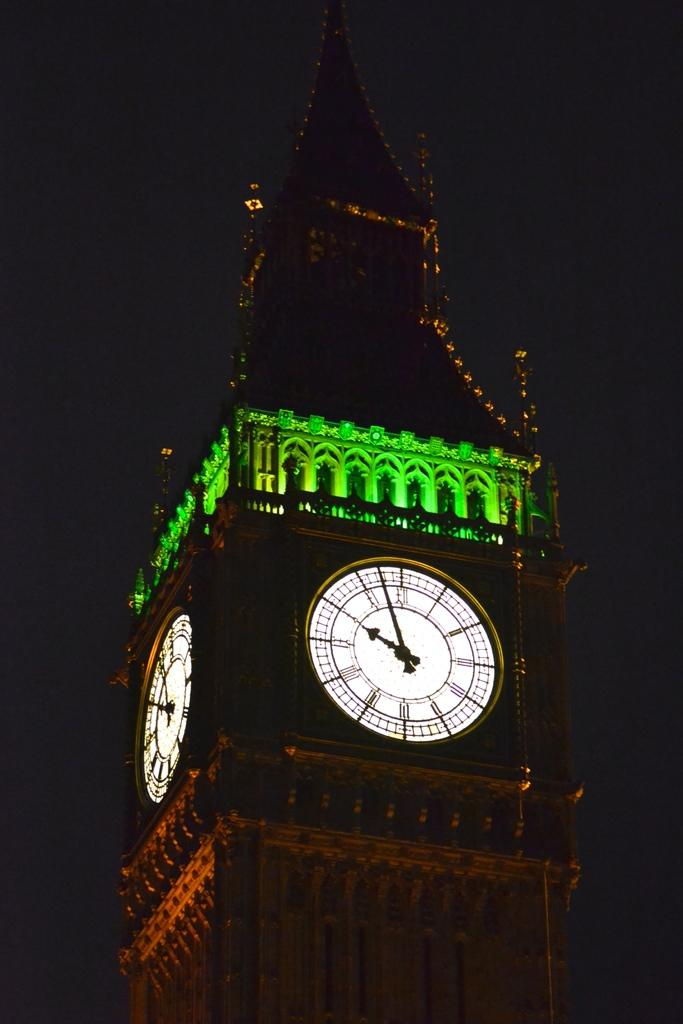What is the main structure in the image? There is a clock tower in the image. How would you describe the lighting in the image? The background of the image is dark. How many ants can be seen crawling on the clock tower in the image? There are no ants present in the image, as it only features a clock tower and a dark background. 